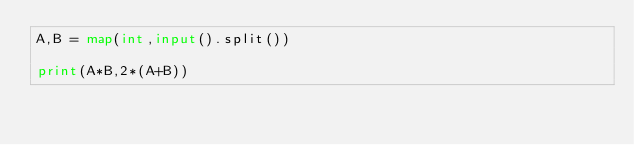<code> <loc_0><loc_0><loc_500><loc_500><_Python_>A,B = map(int,input().split())

print(A*B,2*(A+B))
</code> 